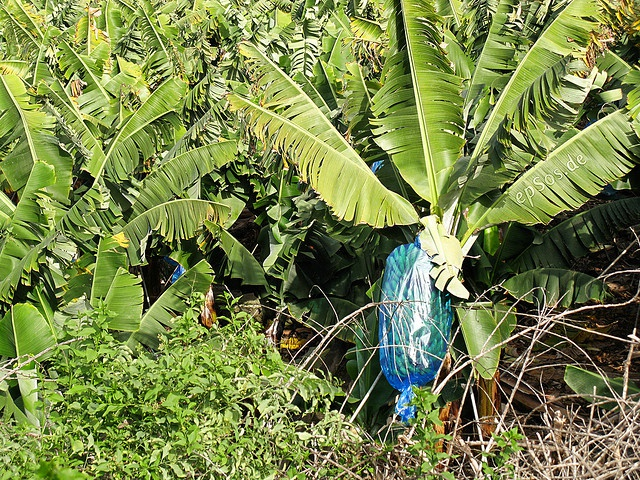Describe the objects in this image and their specific colors. I can see banana in olive, white, teal, and darkgray tones, banana in olive, teal, turquoise, and lightblue tones, banana in olive, tan, maroon, and brown tones, banana in olive and teal tones, and banana in olive, yellow, and tan tones in this image. 